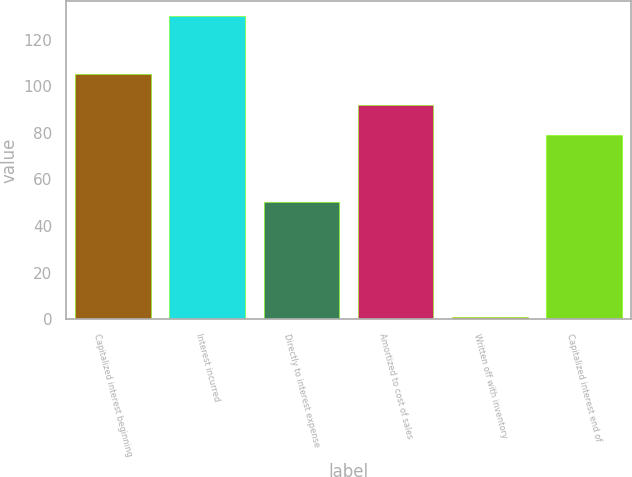Convert chart. <chart><loc_0><loc_0><loc_500><loc_500><bar_chart><fcel>Capitalized interest beginning<fcel>Interest incurred<fcel>Directly to interest expense<fcel>Amortized to cost of sales<fcel>Written off with inventory<fcel>Capitalized interest end of<nl><fcel>105<fcel>130.2<fcel>50.5<fcel>92.1<fcel>1.2<fcel>79.2<nl></chart> 